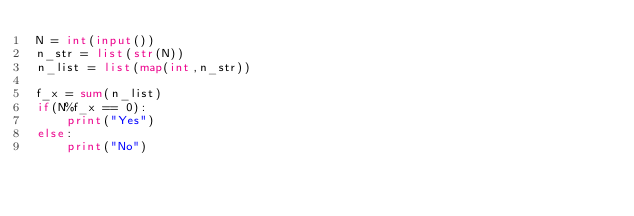Convert code to text. <code><loc_0><loc_0><loc_500><loc_500><_Python_>N = int(input())
n_str = list(str(N))
n_list = list(map(int,n_str))

f_x = sum(n_list)
if(N%f_x == 0):
	print("Yes")
else:
	print("No")</code> 